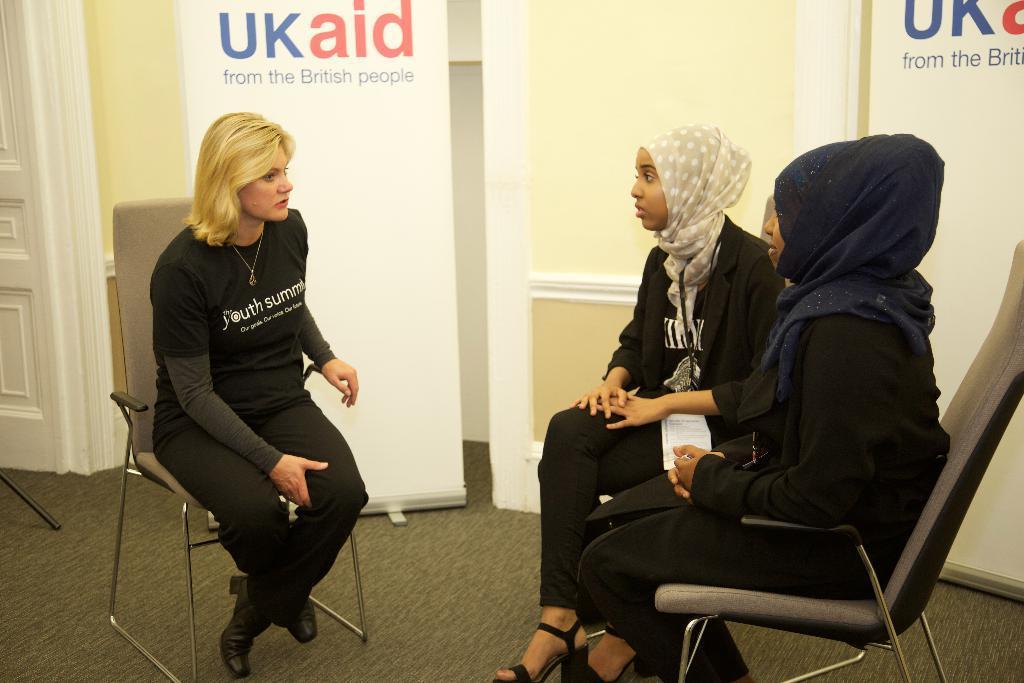Please provide a concise description of this image. In the image we can see three persons were sitting on the chair. And back we can see wall,door and banner. 